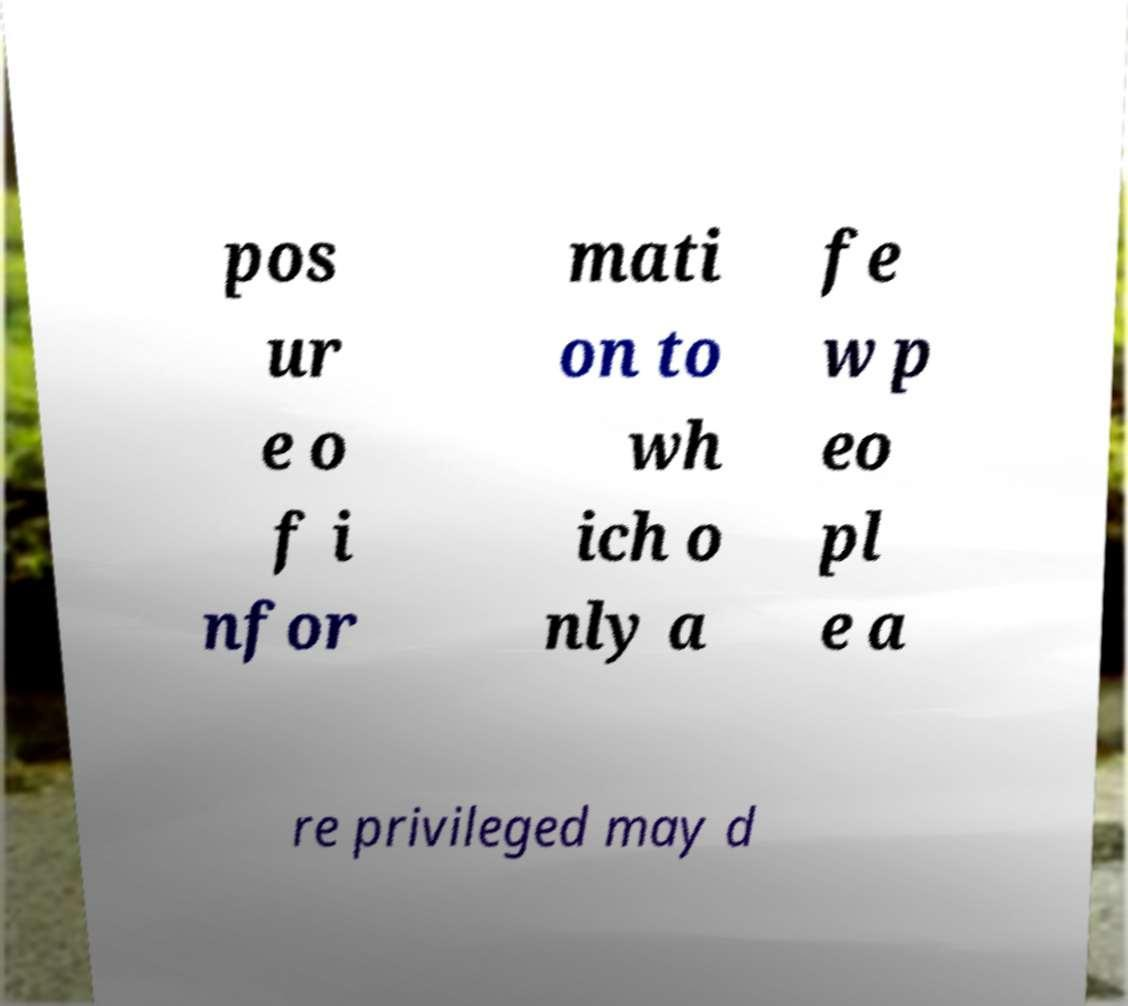There's text embedded in this image that I need extracted. Can you transcribe it verbatim? pos ur e o f i nfor mati on to wh ich o nly a fe w p eo pl e a re privileged may d 